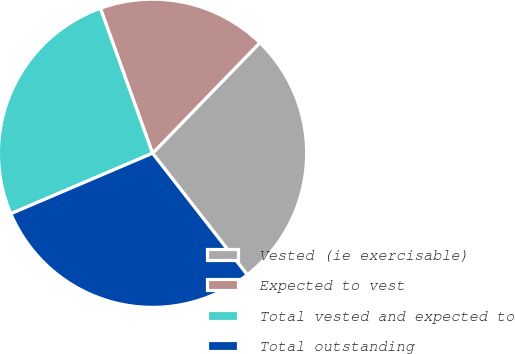Convert chart. <chart><loc_0><loc_0><loc_500><loc_500><pie_chart><fcel>Vested (ie exercisable)<fcel>Expected to vest<fcel>Total vested and expected to<fcel>Total outstanding<nl><fcel>27.2%<fcel>17.76%<fcel>25.92%<fcel>29.12%<nl></chart> 